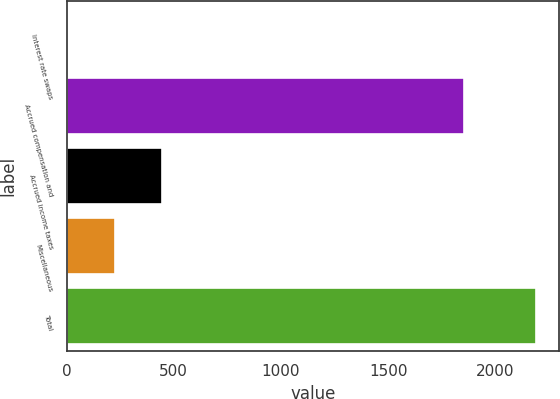Convert chart to OTSL. <chart><loc_0><loc_0><loc_500><loc_500><bar_chart><fcel>Interest rate swaps<fcel>Accrued compensation and<fcel>Accrued income taxes<fcel>Miscellaneous<fcel>Total<nl><fcel>8.9<fcel>1853.1<fcel>445.08<fcel>226.99<fcel>2189.8<nl></chart> 